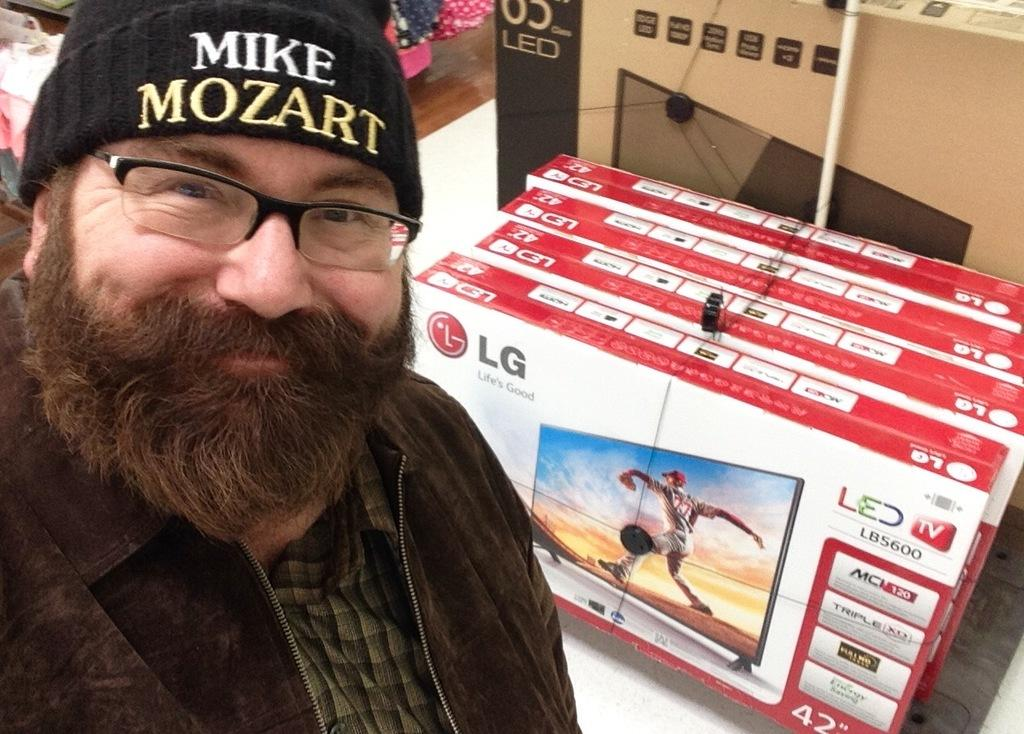Who is in the image? There is a person in the image. What is the person's facial expression? The person has a smile on their face. What can be seen in the cardboard boxes in the image? There are televisions packed in the cardboard boxes in the image. What other objects are present in the image? There are other objects present in the image, but their specific details are not mentioned in the provided facts. What type of yarn is being used to create the wheel in the image? There is no wheel or yarn present in the image. 